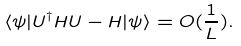Convert formula to latex. <formula><loc_0><loc_0><loc_500><loc_500>\langle \psi | U ^ { \dagger } H U - H | \psi \rangle = O ( \frac { 1 } { L } ) .</formula> 